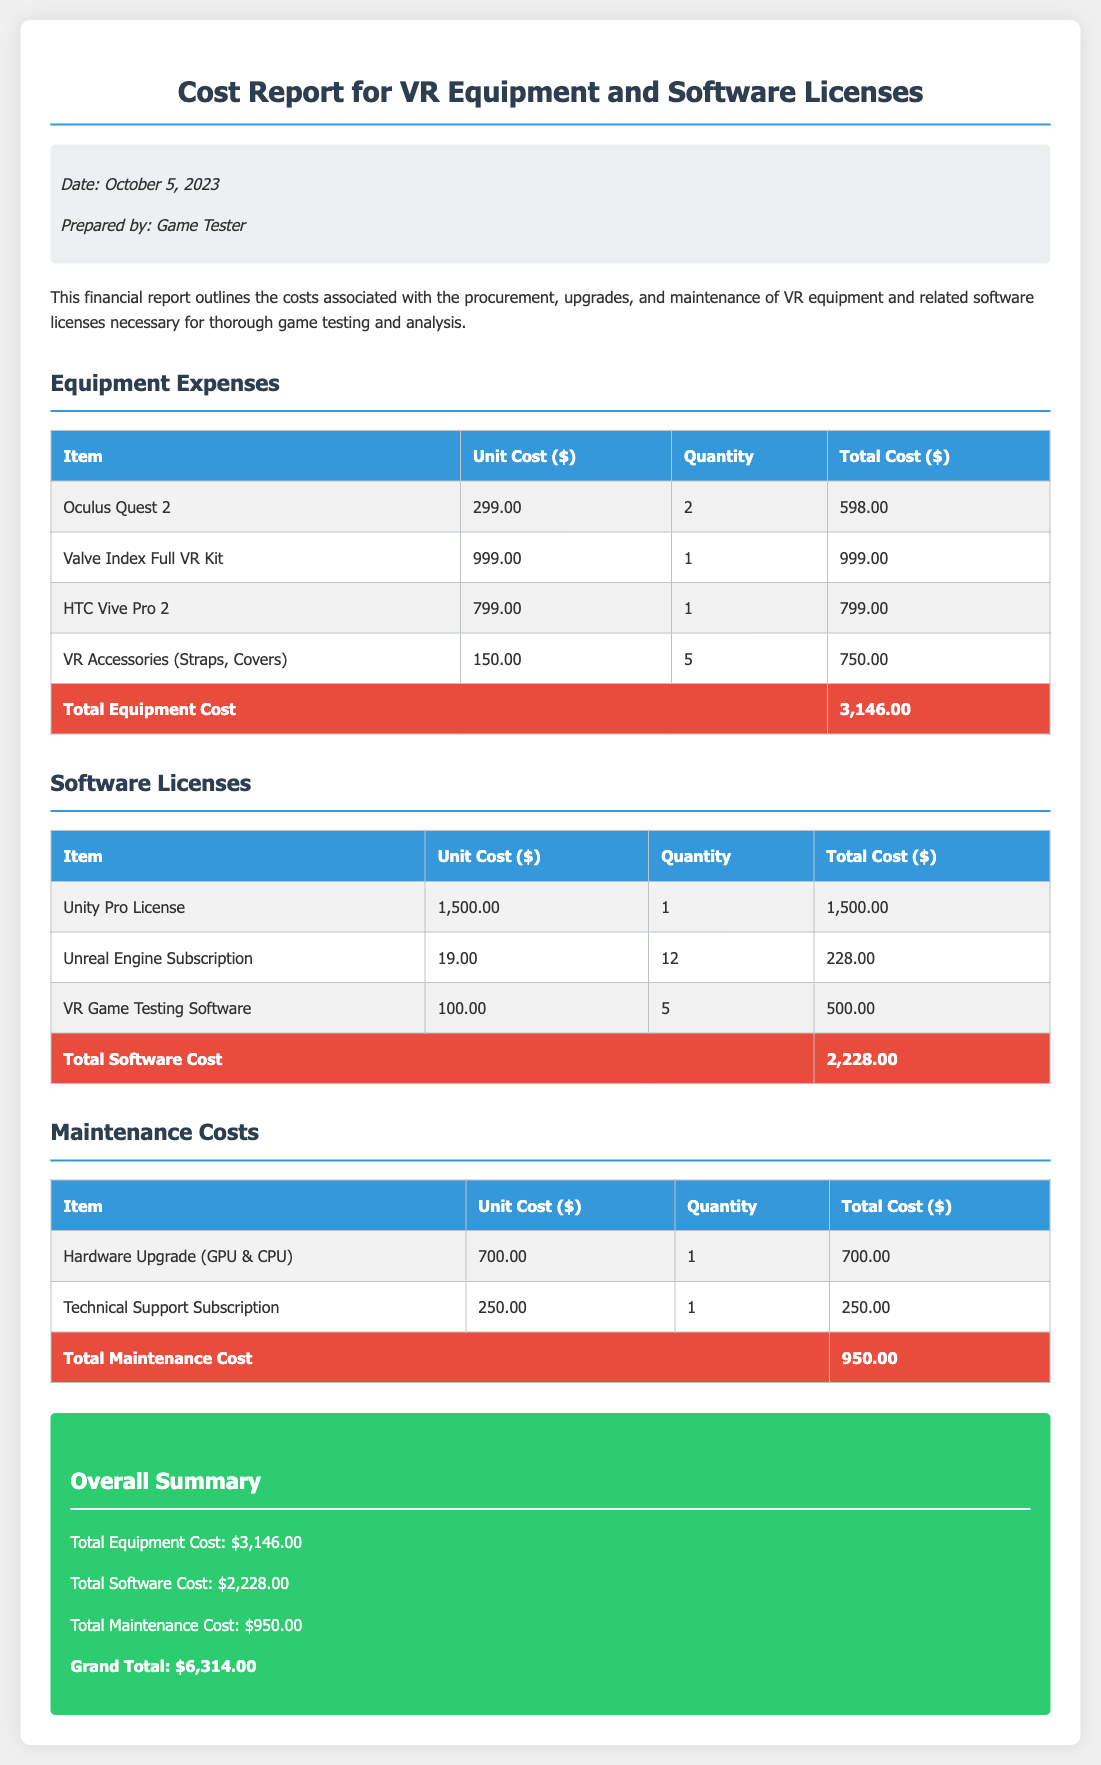What is the total equipment cost? The total equipment cost is provided in the summary of the Equipment Expenses section, which totals $3,146.00.
Answer: $3,146.00 What is the unit cost of the Oculus Quest 2? The unit cost of the Oculus Quest 2 is listed in the Equipment Expenses table under Unit Cost, which is $299.00.
Answer: $299.00 How many Unreal Engine subscriptions were purchased? The quantity of Unreal Engine subscriptions is indicated in the Software Licenses table, which shows 12 as the quantity.
Answer: 12 What is the total software cost? The total software cost is found in the summary of the Software Licenses section, which totals $2,228.00.
Answer: $2,228.00 What item is included under the Maintenance Costs section? The Maintenance Costs table lists Hardware Upgrade (GPU & CPU) as one of the items.
Answer: Hardware Upgrade (GPU & CPU) What is the grand total cost? The grand total is the sum of all costs listed in the Overall Summary section, which is $6,314.00.
Answer: $6,314.00 What is the date of the report? The date of the report is mentioned in the meta-info section at the top, which is October 5, 2023.
Answer: October 5, 2023 What is the total maintenance cost? The total maintenance cost is stated in the summary of the Maintenance Costs section, which totals $950.00.
Answer: $950.00 How many VR accessories were purchased? The number of VR accessories purchased is noted in the Equipment Expenses table, which shows a quantity of 5.
Answer: 5 